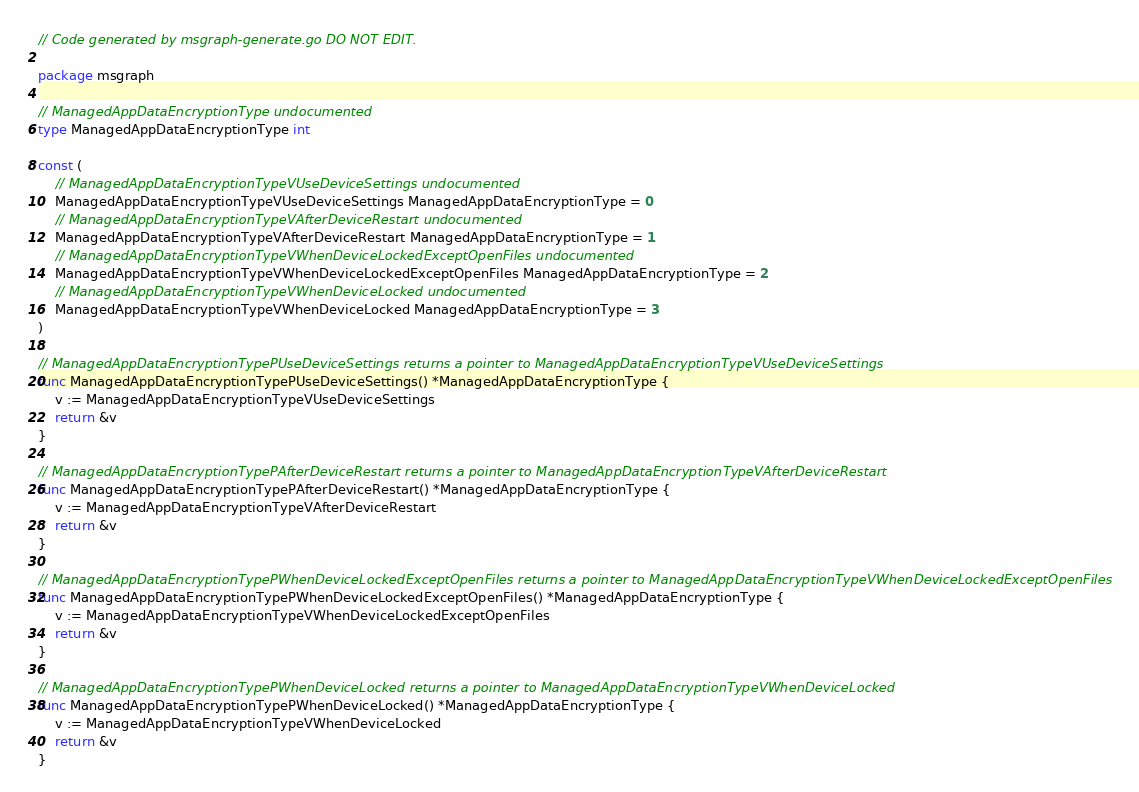Convert code to text. <code><loc_0><loc_0><loc_500><loc_500><_Go_>// Code generated by msgraph-generate.go DO NOT EDIT.

package msgraph

// ManagedAppDataEncryptionType undocumented
type ManagedAppDataEncryptionType int

const (
	// ManagedAppDataEncryptionTypeVUseDeviceSettings undocumented
	ManagedAppDataEncryptionTypeVUseDeviceSettings ManagedAppDataEncryptionType = 0
	// ManagedAppDataEncryptionTypeVAfterDeviceRestart undocumented
	ManagedAppDataEncryptionTypeVAfterDeviceRestart ManagedAppDataEncryptionType = 1
	// ManagedAppDataEncryptionTypeVWhenDeviceLockedExceptOpenFiles undocumented
	ManagedAppDataEncryptionTypeVWhenDeviceLockedExceptOpenFiles ManagedAppDataEncryptionType = 2
	// ManagedAppDataEncryptionTypeVWhenDeviceLocked undocumented
	ManagedAppDataEncryptionTypeVWhenDeviceLocked ManagedAppDataEncryptionType = 3
)

// ManagedAppDataEncryptionTypePUseDeviceSettings returns a pointer to ManagedAppDataEncryptionTypeVUseDeviceSettings
func ManagedAppDataEncryptionTypePUseDeviceSettings() *ManagedAppDataEncryptionType {
	v := ManagedAppDataEncryptionTypeVUseDeviceSettings
	return &v
}

// ManagedAppDataEncryptionTypePAfterDeviceRestart returns a pointer to ManagedAppDataEncryptionTypeVAfterDeviceRestart
func ManagedAppDataEncryptionTypePAfterDeviceRestart() *ManagedAppDataEncryptionType {
	v := ManagedAppDataEncryptionTypeVAfterDeviceRestart
	return &v
}

// ManagedAppDataEncryptionTypePWhenDeviceLockedExceptOpenFiles returns a pointer to ManagedAppDataEncryptionTypeVWhenDeviceLockedExceptOpenFiles
func ManagedAppDataEncryptionTypePWhenDeviceLockedExceptOpenFiles() *ManagedAppDataEncryptionType {
	v := ManagedAppDataEncryptionTypeVWhenDeviceLockedExceptOpenFiles
	return &v
}

// ManagedAppDataEncryptionTypePWhenDeviceLocked returns a pointer to ManagedAppDataEncryptionTypeVWhenDeviceLocked
func ManagedAppDataEncryptionTypePWhenDeviceLocked() *ManagedAppDataEncryptionType {
	v := ManagedAppDataEncryptionTypeVWhenDeviceLocked
	return &v
}
</code> 